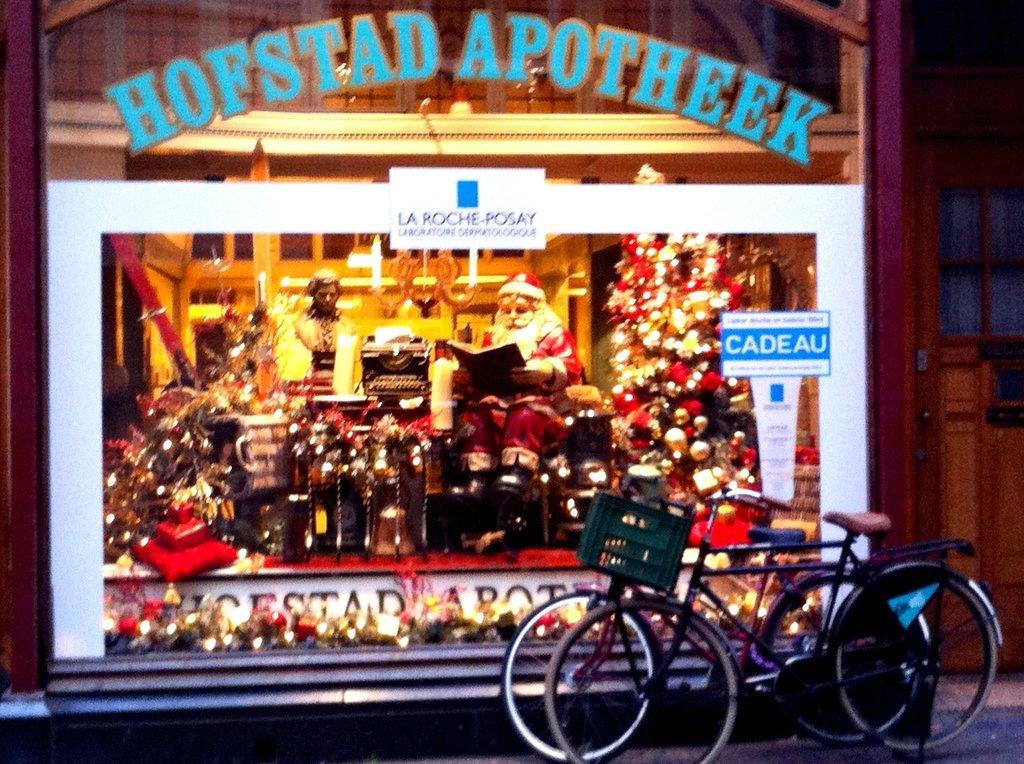In one or two sentences, can you explain what this image depicts? In this image on the right side, I can see two bicycles. I can see a mirror with some text written on it. 